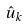Convert formula to latex. <formula><loc_0><loc_0><loc_500><loc_500>\hat { u } _ { k }</formula> 